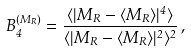<formula> <loc_0><loc_0><loc_500><loc_500>B _ { 4 } ^ { ( M _ { R } ) } = \frac { \langle | M _ { R } - \langle M _ { R } \rangle | ^ { 4 } \rangle } { \langle | M _ { R } - \langle M _ { R } \rangle | ^ { 2 } \rangle ^ { 2 } } \, ,</formula> 